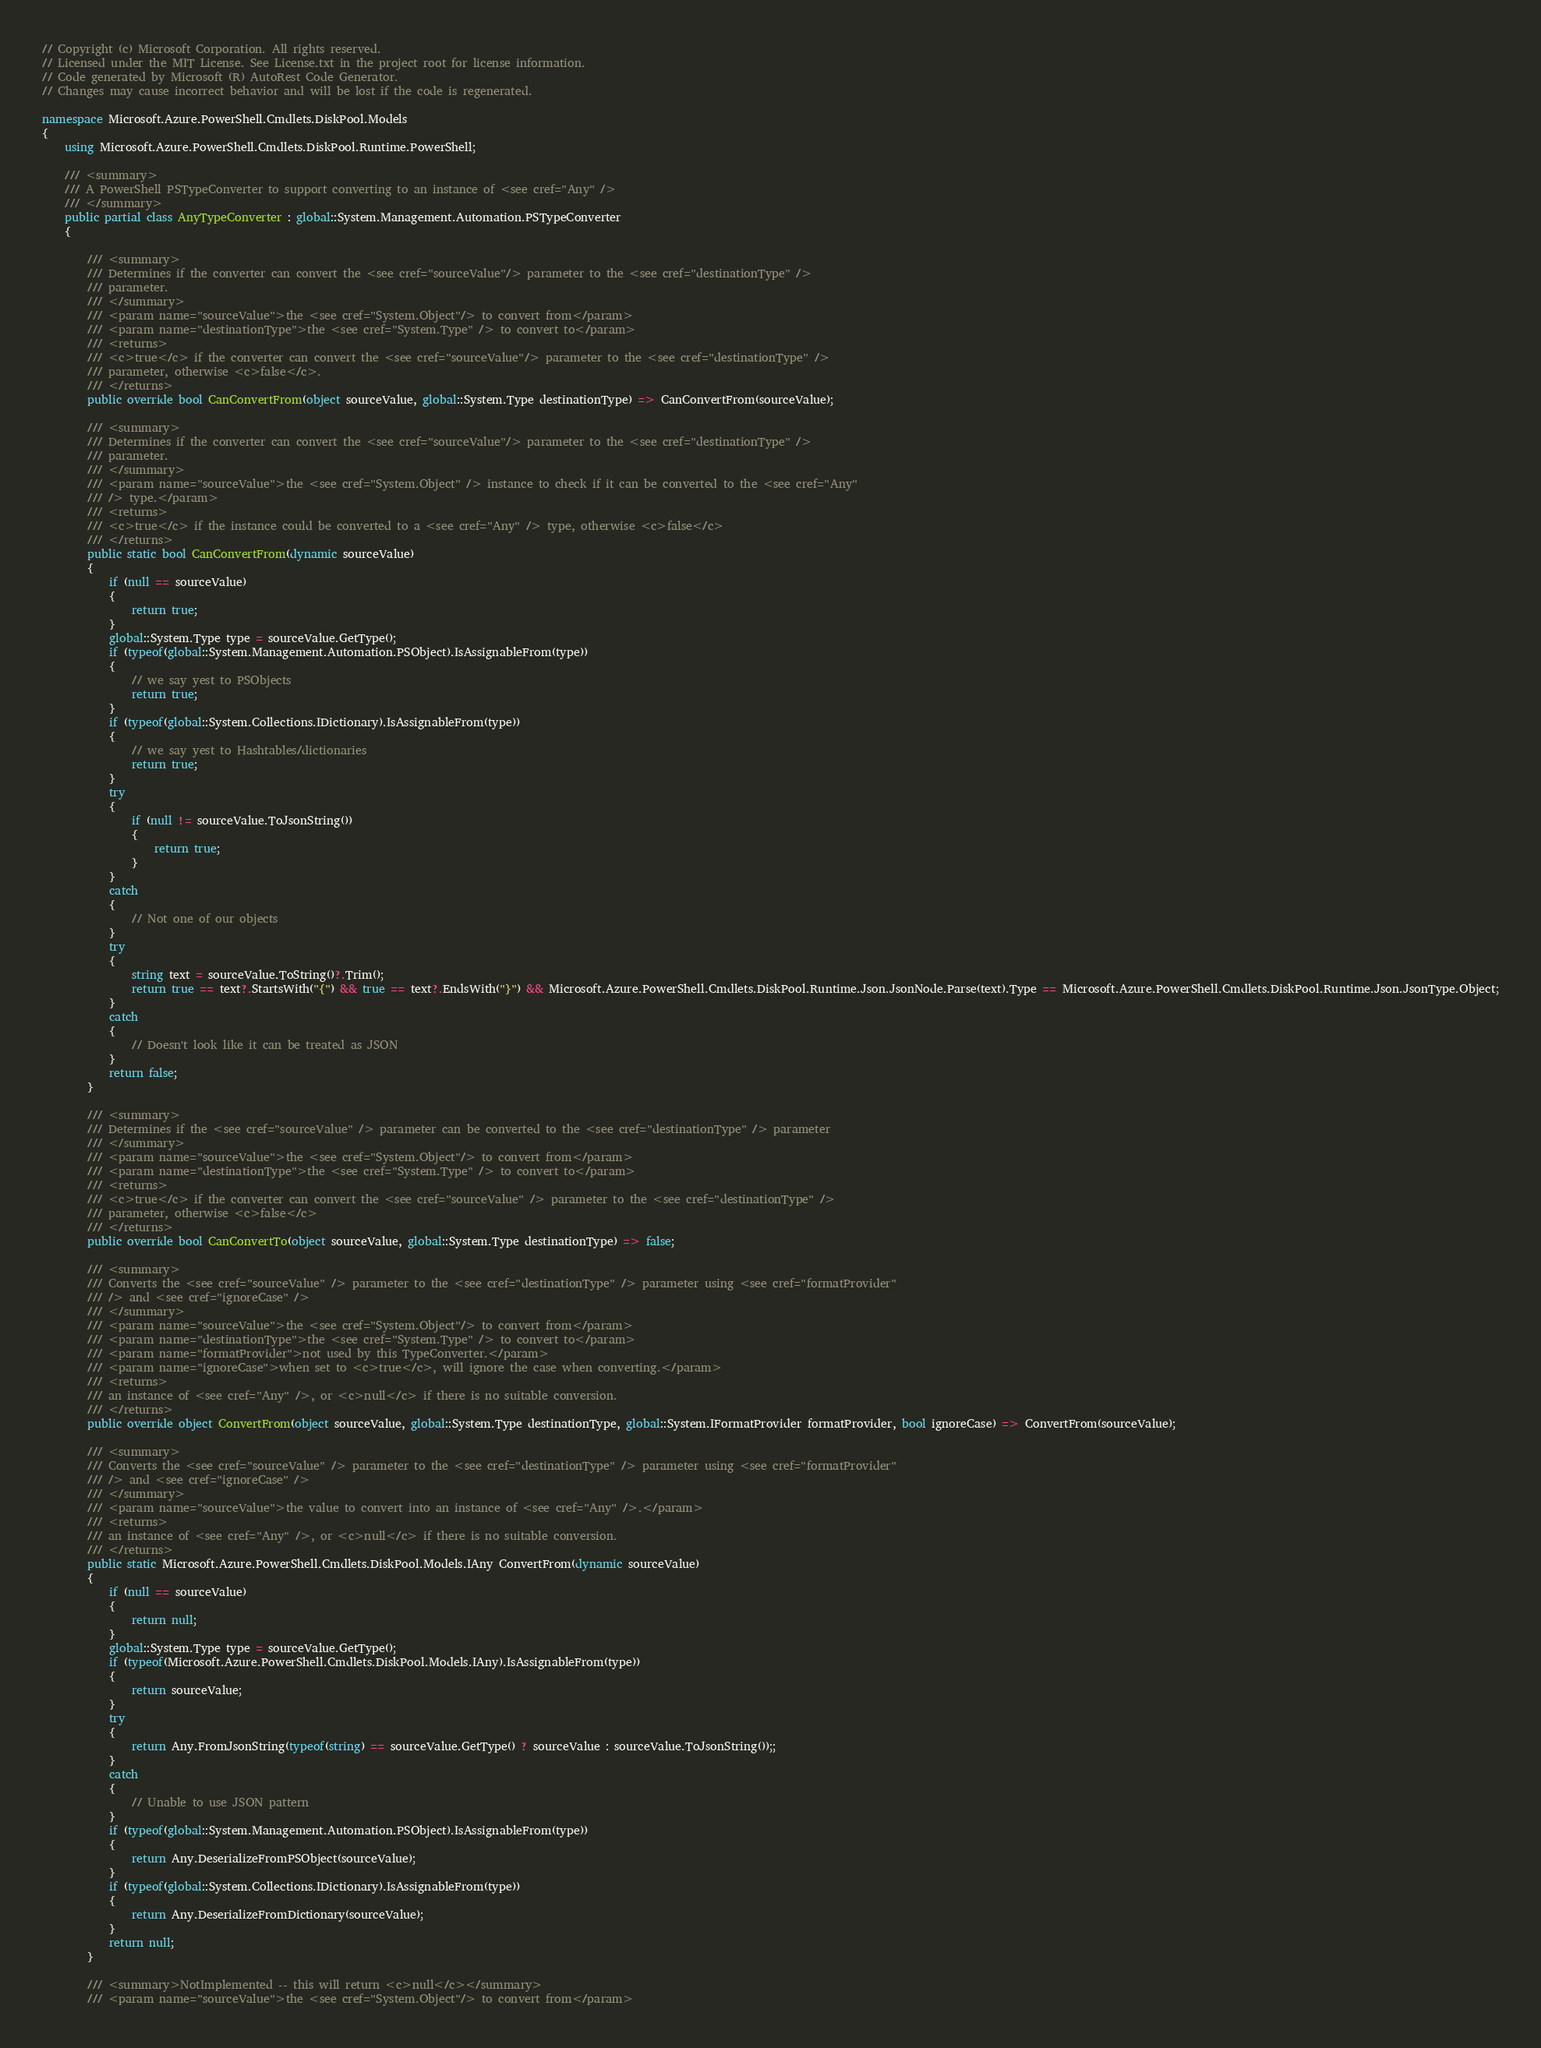<code> <loc_0><loc_0><loc_500><loc_500><_C#_>// Copyright (c) Microsoft Corporation. All rights reserved.
// Licensed under the MIT License. See License.txt in the project root for license information.
// Code generated by Microsoft (R) AutoRest Code Generator.
// Changes may cause incorrect behavior and will be lost if the code is regenerated.

namespace Microsoft.Azure.PowerShell.Cmdlets.DiskPool.Models
{
    using Microsoft.Azure.PowerShell.Cmdlets.DiskPool.Runtime.PowerShell;

    /// <summary>
    /// A PowerShell PSTypeConverter to support converting to an instance of <see cref="Any" />
    /// </summary>
    public partial class AnyTypeConverter : global::System.Management.Automation.PSTypeConverter
    {

        /// <summary>
        /// Determines if the converter can convert the <see cref="sourceValue"/> parameter to the <see cref="destinationType" />
        /// parameter.
        /// </summary>
        /// <param name="sourceValue">the <see cref="System.Object"/> to convert from</param>
        /// <param name="destinationType">the <see cref="System.Type" /> to convert to</param>
        /// <returns>
        /// <c>true</c> if the converter can convert the <see cref="sourceValue"/> parameter to the <see cref="destinationType" />
        /// parameter, otherwise <c>false</c>.
        /// </returns>
        public override bool CanConvertFrom(object sourceValue, global::System.Type destinationType) => CanConvertFrom(sourceValue);

        /// <summary>
        /// Determines if the converter can convert the <see cref="sourceValue"/> parameter to the <see cref="destinationType" />
        /// parameter.
        /// </summary>
        /// <param name="sourceValue">the <see cref="System.Object" /> instance to check if it can be converted to the <see cref="Any"
        /// /> type.</param>
        /// <returns>
        /// <c>true</c> if the instance could be converted to a <see cref="Any" /> type, otherwise <c>false</c>
        /// </returns>
        public static bool CanConvertFrom(dynamic sourceValue)
        {
            if (null == sourceValue)
            {
                return true;
            }
            global::System.Type type = sourceValue.GetType();
            if (typeof(global::System.Management.Automation.PSObject).IsAssignableFrom(type))
            {
                // we say yest to PSObjects
                return true;
            }
            if (typeof(global::System.Collections.IDictionary).IsAssignableFrom(type))
            {
                // we say yest to Hashtables/dictionaries
                return true;
            }
            try
            {
                if (null != sourceValue.ToJsonString())
                {
                    return true;
                }
            }
            catch
            {
                // Not one of our objects
            }
            try
            {
                string text = sourceValue.ToString()?.Trim();
                return true == text?.StartsWith("{") && true == text?.EndsWith("}") && Microsoft.Azure.PowerShell.Cmdlets.DiskPool.Runtime.Json.JsonNode.Parse(text).Type == Microsoft.Azure.PowerShell.Cmdlets.DiskPool.Runtime.Json.JsonType.Object;
            }
            catch
            {
                // Doesn't look like it can be treated as JSON
            }
            return false;
        }

        /// <summary>
        /// Determines if the <see cref="sourceValue" /> parameter can be converted to the <see cref="destinationType" /> parameter
        /// </summary>
        /// <param name="sourceValue">the <see cref="System.Object"/> to convert from</param>
        /// <param name="destinationType">the <see cref="System.Type" /> to convert to</param>
        /// <returns>
        /// <c>true</c> if the converter can convert the <see cref="sourceValue" /> parameter to the <see cref="destinationType" />
        /// parameter, otherwise <c>false</c>
        /// </returns>
        public override bool CanConvertTo(object sourceValue, global::System.Type destinationType) => false;

        /// <summary>
        /// Converts the <see cref="sourceValue" /> parameter to the <see cref="destinationType" /> parameter using <see cref="formatProvider"
        /// /> and <see cref="ignoreCase" />
        /// </summary>
        /// <param name="sourceValue">the <see cref="System.Object"/> to convert from</param>
        /// <param name="destinationType">the <see cref="System.Type" /> to convert to</param>
        /// <param name="formatProvider">not used by this TypeConverter.</param>
        /// <param name="ignoreCase">when set to <c>true</c>, will ignore the case when converting.</param>
        /// <returns>
        /// an instance of <see cref="Any" />, or <c>null</c> if there is no suitable conversion.
        /// </returns>
        public override object ConvertFrom(object sourceValue, global::System.Type destinationType, global::System.IFormatProvider formatProvider, bool ignoreCase) => ConvertFrom(sourceValue);

        /// <summary>
        /// Converts the <see cref="sourceValue" /> parameter to the <see cref="destinationType" /> parameter using <see cref="formatProvider"
        /// /> and <see cref="ignoreCase" />
        /// </summary>
        /// <param name="sourceValue">the value to convert into an instance of <see cref="Any" />.</param>
        /// <returns>
        /// an instance of <see cref="Any" />, or <c>null</c> if there is no suitable conversion.
        /// </returns>
        public static Microsoft.Azure.PowerShell.Cmdlets.DiskPool.Models.IAny ConvertFrom(dynamic sourceValue)
        {
            if (null == sourceValue)
            {
                return null;
            }
            global::System.Type type = sourceValue.GetType();
            if (typeof(Microsoft.Azure.PowerShell.Cmdlets.DiskPool.Models.IAny).IsAssignableFrom(type))
            {
                return sourceValue;
            }
            try
            {
                return Any.FromJsonString(typeof(string) == sourceValue.GetType() ? sourceValue : sourceValue.ToJsonString());;
            }
            catch
            {
                // Unable to use JSON pattern
            }
            if (typeof(global::System.Management.Automation.PSObject).IsAssignableFrom(type))
            {
                return Any.DeserializeFromPSObject(sourceValue);
            }
            if (typeof(global::System.Collections.IDictionary).IsAssignableFrom(type))
            {
                return Any.DeserializeFromDictionary(sourceValue);
            }
            return null;
        }

        /// <summary>NotImplemented -- this will return <c>null</c></summary>
        /// <param name="sourceValue">the <see cref="System.Object"/> to convert from</param></code> 